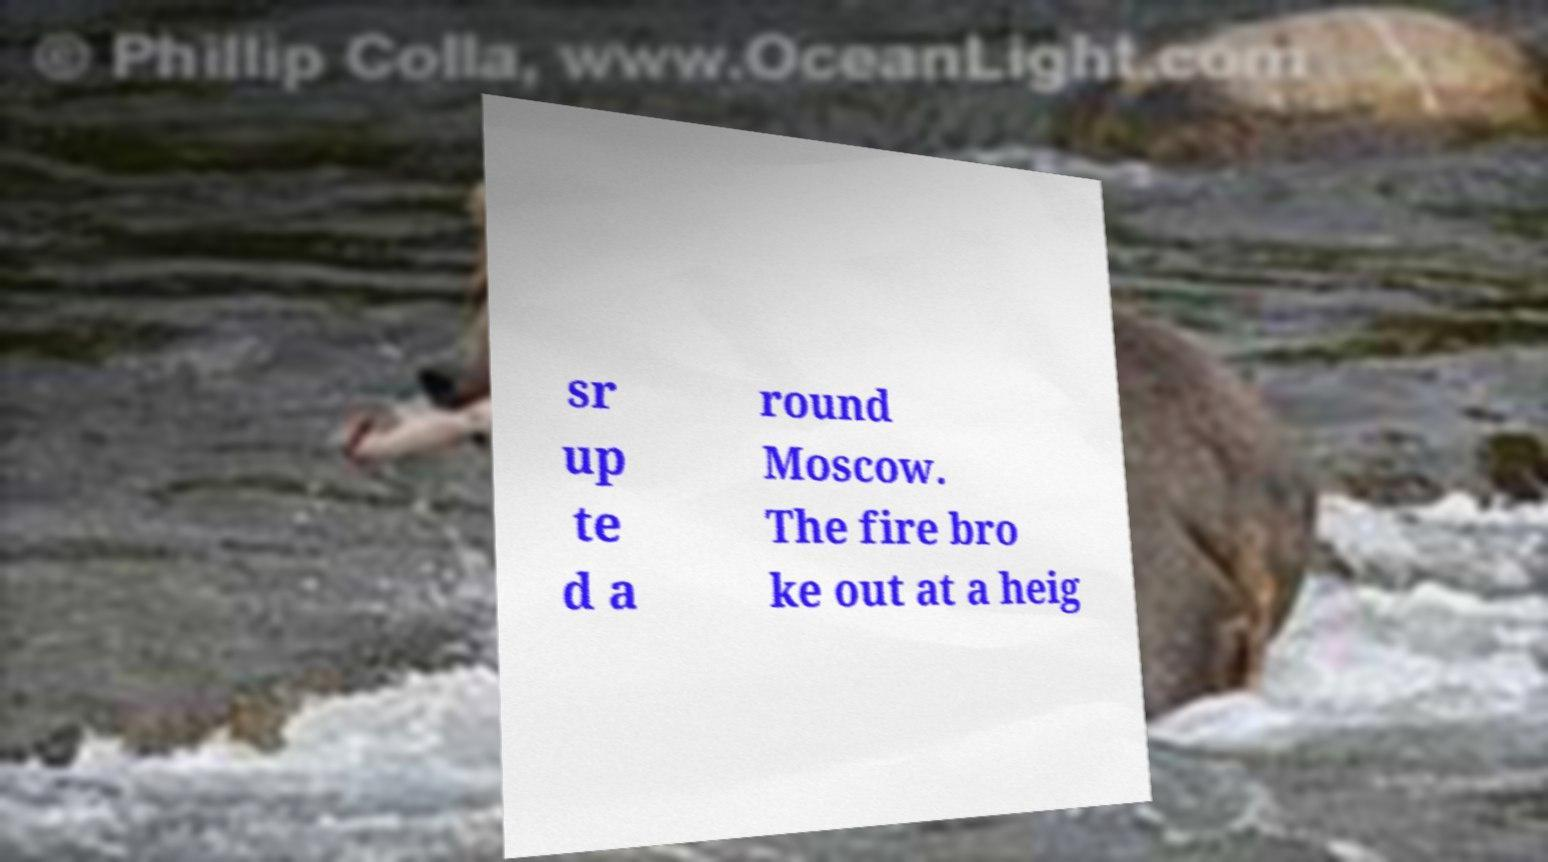For documentation purposes, I need the text within this image transcribed. Could you provide that? sr up te d a round Moscow. The fire bro ke out at a heig 